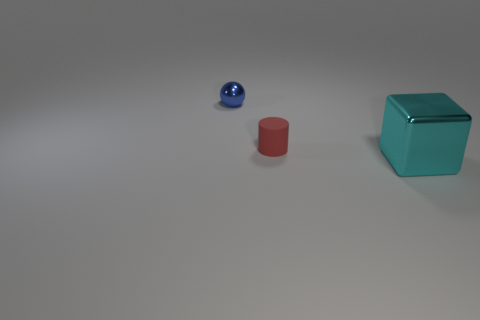How many objects are green balls or blue shiny objects?
Give a very brief answer. 1. What is the color of the rubber cylinder that is the same size as the blue shiny sphere?
Offer a terse response. Red. What number of things are either small objects that are right of the small blue shiny sphere or red cylinders?
Offer a very short reply. 1. What number of other things are the same size as the ball?
Provide a short and direct response. 1. There is a thing that is right of the red rubber cylinder; what is its size?
Your response must be concise. Large. There is a cyan object that is the same material as the tiny blue thing; what is its shape?
Provide a short and direct response. Cube. Is there anything else of the same color as the matte cylinder?
Make the answer very short. No. There is a shiny object in front of the metallic object that is to the left of the big thing; what color is it?
Provide a succinct answer. Cyan. What number of big things are either red rubber cylinders or brown blocks?
Offer a very short reply. 0. Is there any other thing that is made of the same material as the small red object?
Your response must be concise. No. 